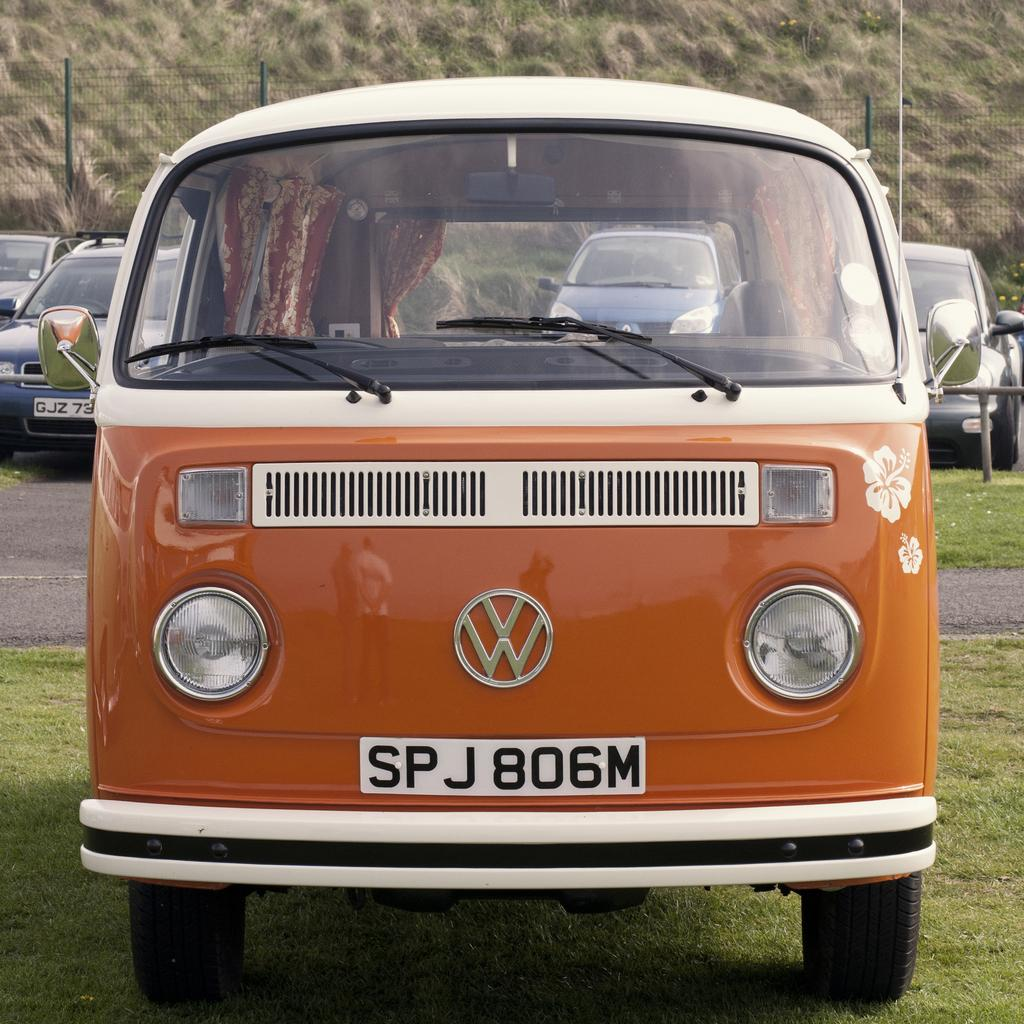Provide a one-sentence caption for the provided image. front of an orange bus made by volkswagon auto. 